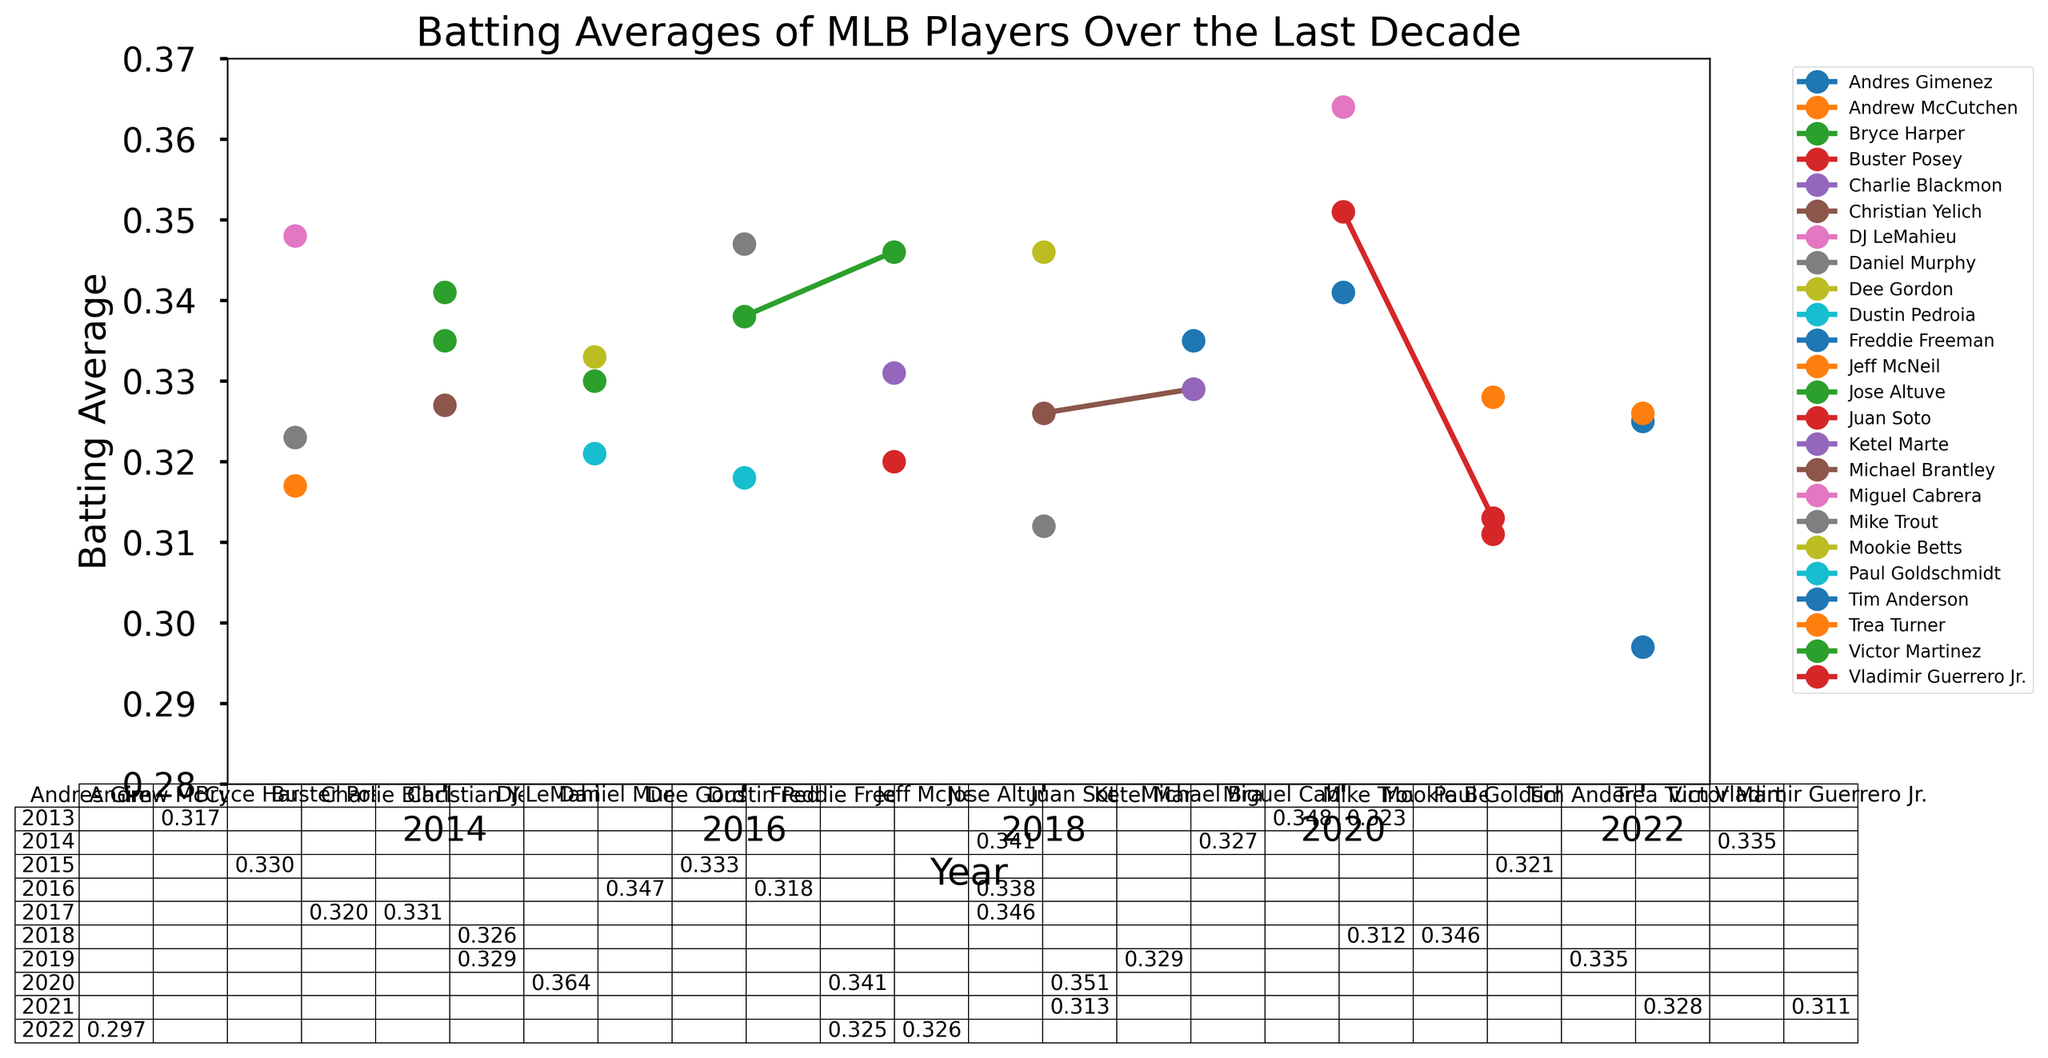What was Mike Trout's batting average in 2013 compared to 2018? To find Mike Trout's batting averages for 2013 and 2018, look at his plots for those years. In 2013, his average was 0.323, and in 2018, it was 0.312.
Answer: 0.323 in 2013, 0.312 in 2018 Which player had the highest batting average in 2020? To identify the player with the highest batting average in 2020, check the table and the plot lines for 2020. DJ LeMahieu had the highest batting average of 0.364.
Answer: DJ LeMahieu How did Jose Altuve's batting averages change from 2014 to 2017? Look at Jose Altuve's batting averages for the years 2014, 2016, and 2017. They were 0.341 in 2014, 0.338 in 2016, and 0.346 in 2017, showing a small drop in 2016 but an overall increase.
Answer: Increased overall Which team had the most players featured in the batting average table over the last decade? To find the team with the most players, count the occurrences of each team in the table. The Washington Nationals appear the most frequently with four different players.
Answer: Washington Nationals What's the difference between the highest and lowest batting averages in 2021? Find the highest and lowest averages from the 2021 columns in the plot. Trea Turner had 0.328 and Juan Soto had 0.313, making the difference 0.328 - 0.313.
Answer: 0.015 Did any player appear on the list for multiple teams? Who are they and for which teams? Look for players who appear with different teams in the table over the years. Freddie Freeman is the only player who appears for two teams: Atlanta Braves and Los Angeles Dodgers.
Answer: Freddie Freeman - Atlanta Braves and Los Angeles Dodgers What visual trends do you notice in the batting averages from 2016 to 2017? Check the plots between 2016 and 2017. Visually, there are several lines that show an increase in batting averages, notably Jose Altuve and Charlie Blackmon.
Answer: Increasing averages Which year had the most players with batting averages above 0.330? Count the number of players with averages above 0.330 for each year by looking at the plot and table. 2020 had the most players with batting averages above 0.330 with three players.
Answer: 2020 Compare the batting averages of Juan Soto for 2020 and 2021. Find Juan Soto's batting averages for 2020 and 2021 in the plot. In 2020, it was 0.351, and in 2021, it was 0.313.
Answer: 0.351 in 2020, 0.313 in 2021 Who had the lowest batting average in 2022, and what was it? Check the table and plot for 2022 and find the lowest value. Andres Gimenez had the lowest batting average at 0.297.
Answer: Andres Gimenez, 0.297 